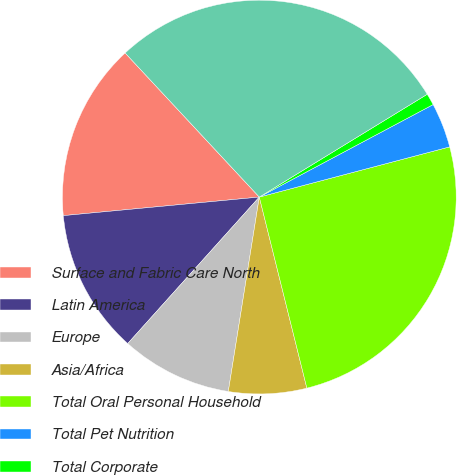Convert chart to OTSL. <chart><loc_0><loc_0><loc_500><loc_500><pie_chart><fcel>Surface and Fabric Care North<fcel>Latin America<fcel>Europe<fcel>Asia/Africa<fcel>Total Oral Personal Household<fcel>Total Pet Nutrition<fcel>Total Corporate<fcel>Total Identifiable Assets (1)<nl><fcel>14.57%<fcel>11.85%<fcel>9.13%<fcel>6.4%<fcel>25.22%<fcel>3.68%<fcel>0.96%<fcel>28.19%<nl></chart> 